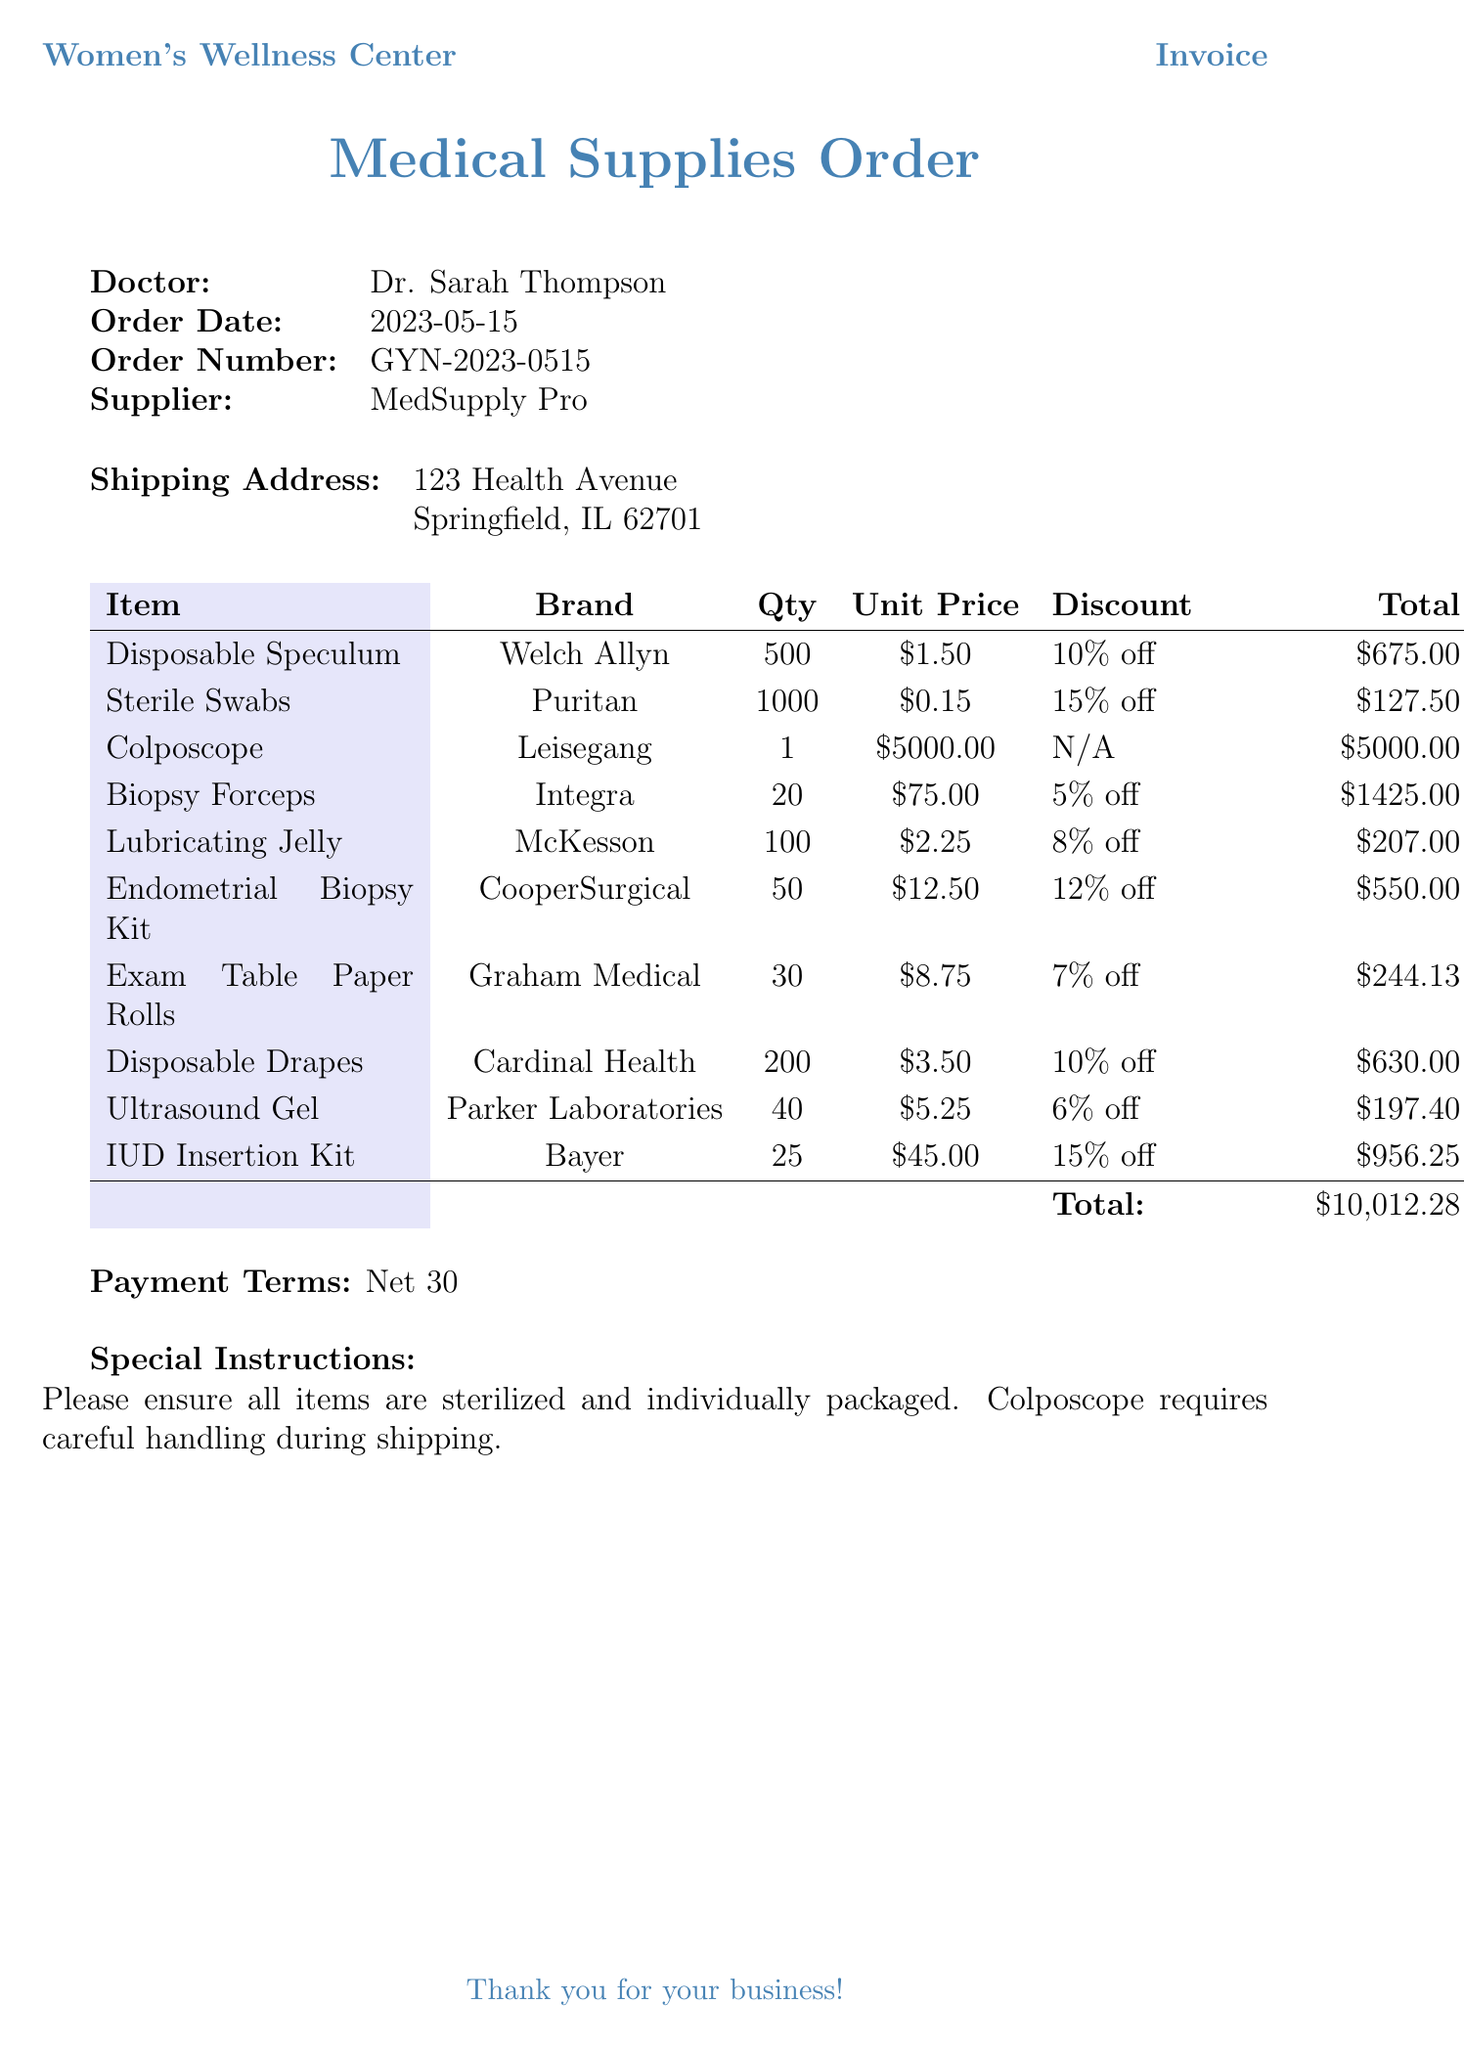What is the name of the clinic? The invoice identifies the clinic as the "Women's Wellness Center."
Answer: Women's Wellness Center Who is the doctor associated with this order? The document specifies Dr. Sarah Thompson as the doctor placing the order.
Answer: Dr. Sarah Thompson What is the order date? The order date is mentioned in the document as May 15, 2023.
Answer: 2023-05-15 How many Disposable Speculums are ordered? The document lists that 500 units of Disposable Speculum were ordered.
Answer: 500 What discount applies to the Sterile Swabs? The document states a 15% discount for orders over 800 units of Sterile Swabs.
Answer: 15% off What is the total amount due for this order? The document totals all items and specifies the total amount due as $10,012.28.
Answer: $10,012.28 What special instruction is included for the Colposcope? The invoice includes a special instruction regarding careful handling during shipping for the Colposcope.
Answer: Careful handling during shipping What payment terms are specified in the document? The document specifies "Net 30" as the payment terms for this order.
Answer: Net 30 How many Exam Table Paper Rolls were ordered? The order specifies that 30 units of Exam Table Paper Rolls were ordered.
Answer: 30 